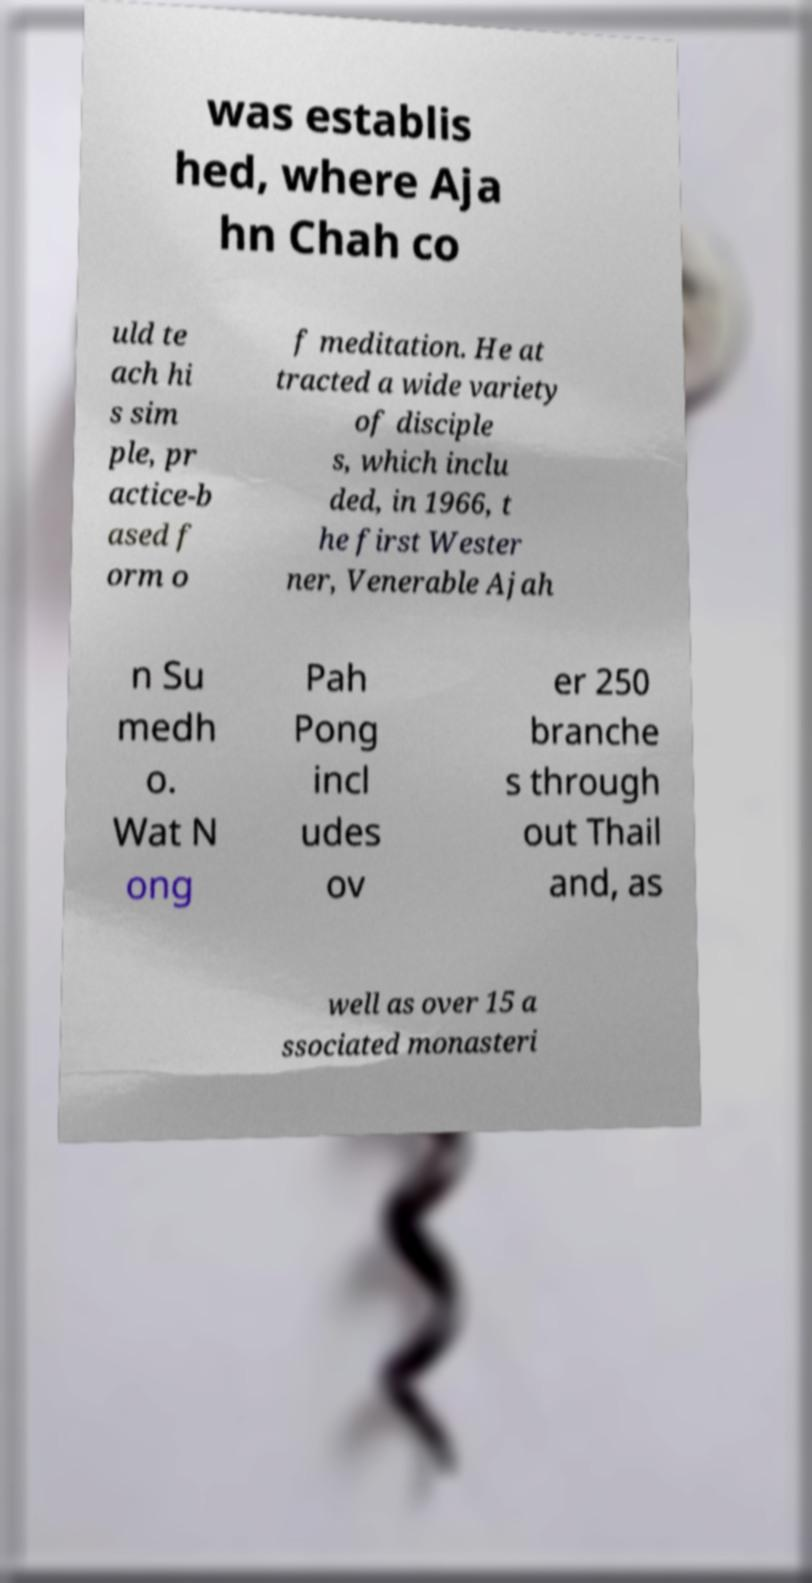What messages or text are displayed in this image? I need them in a readable, typed format. was establis hed, where Aja hn Chah co uld te ach hi s sim ple, pr actice-b ased f orm o f meditation. He at tracted a wide variety of disciple s, which inclu ded, in 1966, t he first Wester ner, Venerable Ajah n Su medh o. Wat N ong Pah Pong incl udes ov er 250 branche s through out Thail and, as well as over 15 a ssociated monasteri 